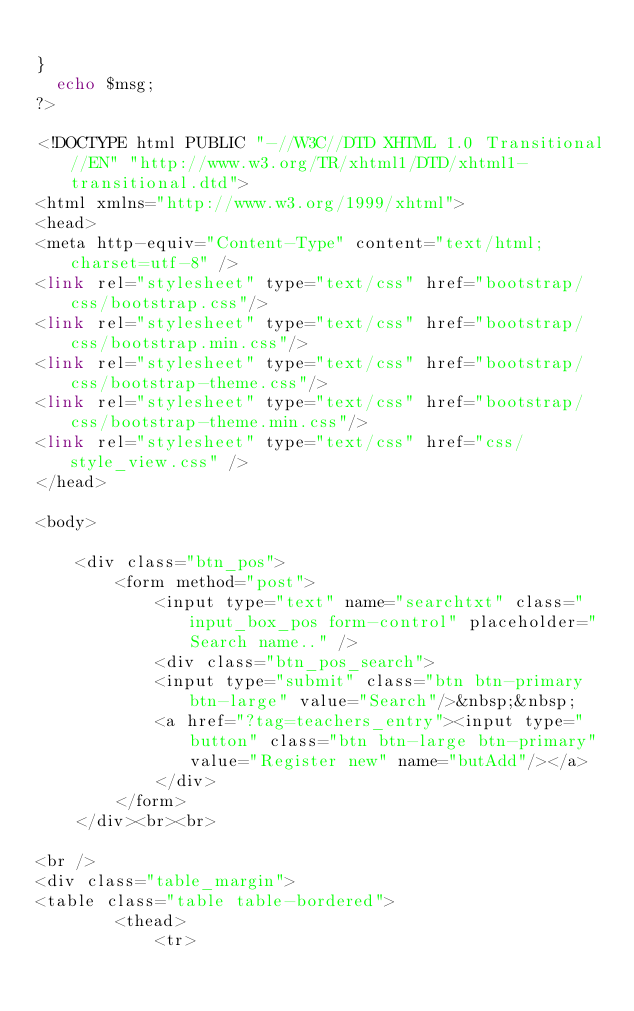Convert code to text. <code><loc_0><loc_0><loc_500><loc_500><_PHP_>			
}
	echo $msg;
?>

<!DOCTYPE html PUBLIC "-//W3C//DTD XHTML 1.0 Transitional//EN" "http://www.w3.org/TR/xhtml1/DTD/xhtml1-transitional.dtd">
<html xmlns="http://www.w3.org/1999/xhtml">
<head>
<meta http-equiv="Content-Type" content="text/html; charset=utf-8" />
<link rel="stylesheet" type="text/css" href="bootstrap/css/bootstrap.css"/>
<link rel="stylesheet" type="text/css" href="bootstrap/css/bootstrap.min.css"/>
<link rel="stylesheet" type="text/css" href="bootstrap/css/bootstrap-theme.css"/>
<link rel="stylesheet" type="text/css" href="bootstrap/css/bootstrap-theme.min.css"/>
<link rel="stylesheet" type="text/css" href="css/style_view.css" />
</head>

<body>

    <div class="btn_pos">
        <form method="post">
            <input type="text" name="searchtxt" class="input_box_pos form-control" placeholder="Search name.." />
            <div class="btn_pos_search">
            <input type="submit" class="btn btn-primary btn-large" value="Search"/>&nbsp;&nbsp;
            <a href="?tag=teachers_entry"><input type="button" class="btn btn-large btn-primary" value="Register new" name="butAdd"/></a>
            </div>
        </form>
    </div><br><br>
    
<br />
<div class="table_margin">
<table class="table table-bordered">
        <thead>
            <tr></code> 